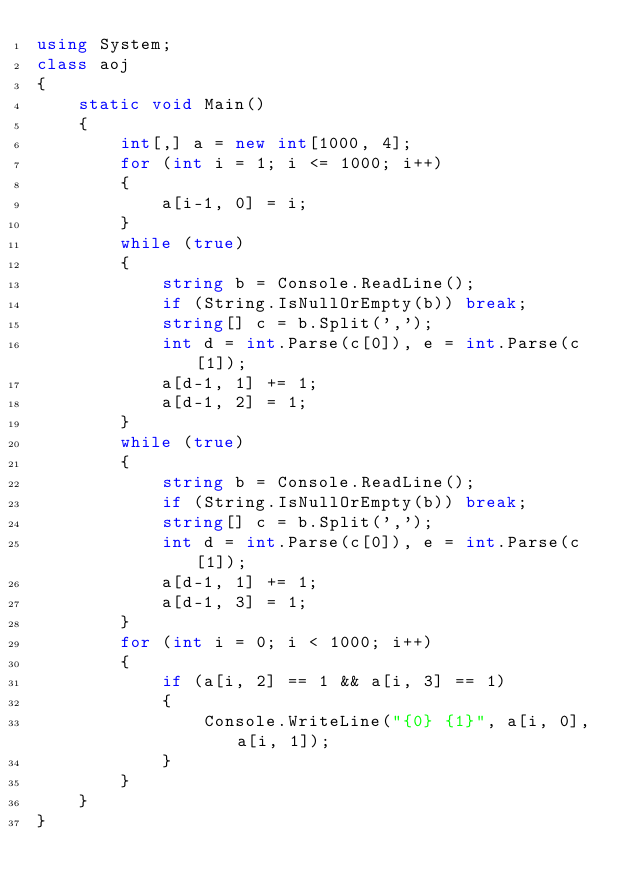Convert code to text. <code><loc_0><loc_0><loc_500><loc_500><_C#_>using System;
class aoj
{
    static void Main()
    {
        int[,] a = new int[1000, 4];
        for (int i = 1; i <= 1000; i++)
        {
            a[i-1, 0] = i;
        }
        while (true)
        {
            string b = Console.ReadLine();
            if (String.IsNullOrEmpty(b)) break;
            string[] c = b.Split(',');
            int d = int.Parse(c[0]), e = int.Parse(c[1]);
            a[d-1, 1] += 1;
            a[d-1, 2] = 1;
        }
        while (true)
        {
            string b = Console.ReadLine();
            if (String.IsNullOrEmpty(b)) break;
            string[] c = b.Split(',');
            int d = int.Parse(c[0]), e = int.Parse(c[1]);
            a[d-1, 1] += 1;
            a[d-1, 3] = 1;
        }
        for (int i = 0; i < 1000; i++)
        {
            if (a[i, 2] == 1 && a[i, 3] == 1)
            {
                Console.WriteLine("{0} {1}", a[i, 0], a[i, 1]);
            }
        }
    }
}</code> 